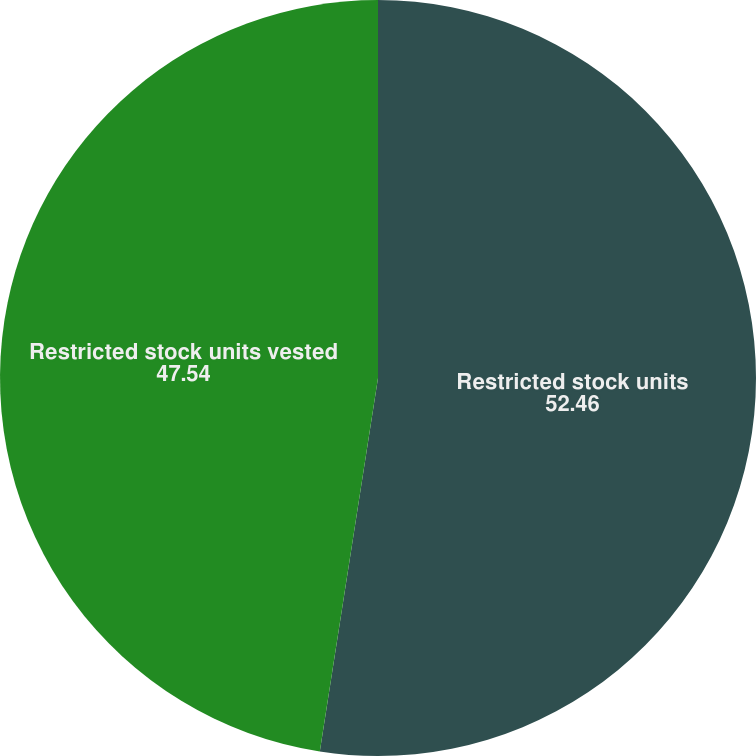Convert chart. <chart><loc_0><loc_0><loc_500><loc_500><pie_chart><fcel>Restricted stock units<fcel>Restricted stock units vested<nl><fcel>52.46%<fcel>47.54%<nl></chart> 